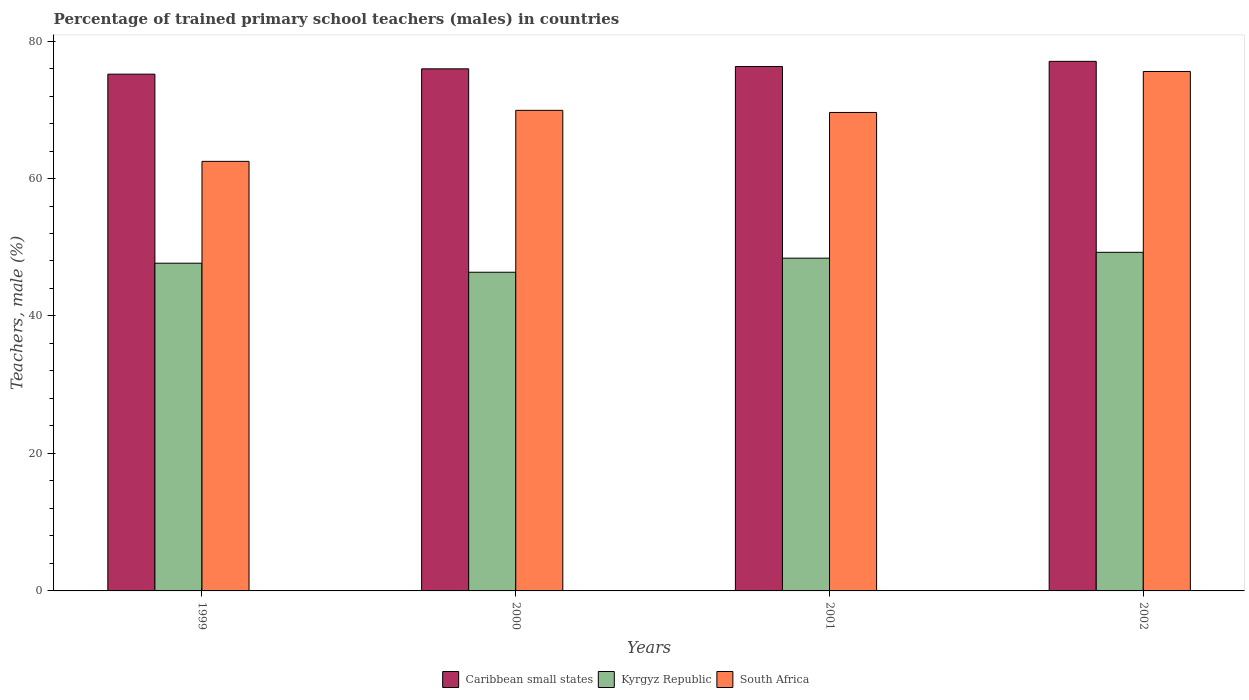How many different coloured bars are there?
Your answer should be very brief. 3. How many groups of bars are there?
Your answer should be compact. 4. Are the number of bars per tick equal to the number of legend labels?
Make the answer very short. Yes. Are the number of bars on each tick of the X-axis equal?
Your response must be concise. Yes. How many bars are there on the 4th tick from the right?
Offer a terse response. 3. What is the label of the 2nd group of bars from the left?
Your answer should be compact. 2000. In how many cases, is the number of bars for a given year not equal to the number of legend labels?
Provide a short and direct response. 0. What is the percentage of trained primary school teachers (males) in Kyrgyz Republic in 2001?
Keep it short and to the point. 48.41. Across all years, what is the maximum percentage of trained primary school teachers (males) in Caribbean small states?
Give a very brief answer. 77.04. Across all years, what is the minimum percentage of trained primary school teachers (males) in South Africa?
Offer a terse response. 62.49. What is the total percentage of trained primary school teachers (males) in Caribbean small states in the graph?
Provide a succinct answer. 304.48. What is the difference between the percentage of trained primary school teachers (males) in South Africa in 2001 and that in 2002?
Provide a succinct answer. -5.96. What is the difference between the percentage of trained primary school teachers (males) in South Africa in 2000 and the percentage of trained primary school teachers (males) in Caribbean small states in 2002?
Your answer should be very brief. -7.13. What is the average percentage of trained primary school teachers (males) in Kyrgyz Republic per year?
Your answer should be very brief. 47.93. In the year 1999, what is the difference between the percentage of trained primary school teachers (males) in Kyrgyz Republic and percentage of trained primary school teachers (males) in Caribbean small states?
Your answer should be compact. -27.5. In how many years, is the percentage of trained primary school teachers (males) in South Africa greater than 40 %?
Keep it short and to the point. 4. What is the ratio of the percentage of trained primary school teachers (males) in South Africa in 2001 to that in 2002?
Your answer should be very brief. 0.92. Is the difference between the percentage of trained primary school teachers (males) in Kyrgyz Republic in 1999 and 2001 greater than the difference between the percentage of trained primary school teachers (males) in Caribbean small states in 1999 and 2001?
Offer a terse response. Yes. What is the difference between the highest and the second highest percentage of trained primary school teachers (males) in South Africa?
Provide a short and direct response. 5.65. What is the difference between the highest and the lowest percentage of trained primary school teachers (males) in South Africa?
Provide a short and direct response. 13.08. In how many years, is the percentage of trained primary school teachers (males) in Kyrgyz Republic greater than the average percentage of trained primary school teachers (males) in Kyrgyz Republic taken over all years?
Give a very brief answer. 2. Is the sum of the percentage of trained primary school teachers (males) in Caribbean small states in 1999 and 2001 greater than the maximum percentage of trained primary school teachers (males) in Kyrgyz Republic across all years?
Offer a terse response. Yes. What does the 2nd bar from the left in 2002 represents?
Offer a very short reply. Kyrgyz Republic. What does the 1st bar from the right in 2001 represents?
Your response must be concise. South Africa. Is it the case that in every year, the sum of the percentage of trained primary school teachers (males) in Kyrgyz Republic and percentage of trained primary school teachers (males) in South Africa is greater than the percentage of trained primary school teachers (males) in Caribbean small states?
Ensure brevity in your answer.  Yes. What is the difference between two consecutive major ticks on the Y-axis?
Ensure brevity in your answer.  20. Does the graph contain any zero values?
Offer a very short reply. No. How many legend labels are there?
Give a very brief answer. 3. What is the title of the graph?
Your response must be concise. Percentage of trained primary school teachers (males) in countries. Does "Slovak Republic" appear as one of the legend labels in the graph?
Give a very brief answer. No. What is the label or title of the Y-axis?
Your answer should be compact. Teachers, male (%). What is the Teachers, male (%) of Caribbean small states in 1999?
Ensure brevity in your answer.  75.18. What is the Teachers, male (%) in Kyrgyz Republic in 1999?
Your answer should be very brief. 47.68. What is the Teachers, male (%) of South Africa in 1999?
Keep it short and to the point. 62.49. What is the Teachers, male (%) in Caribbean small states in 2000?
Your response must be concise. 75.96. What is the Teachers, male (%) of Kyrgyz Republic in 2000?
Provide a short and direct response. 46.36. What is the Teachers, male (%) of South Africa in 2000?
Your answer should be compact. 69.92. What is the Teachers, male (%) in Caribbean small states in 2001?
Your response must be concise. 76.3. What is the Teachers, male (%) in Kyrgyz Republic in 2001?
Provide a succinct answer. 48.41. What is the Teachers, male (%) in South Africa in 2001?
Keep it short and to the point. 69.61. What is the Teachers, male (%) of Caribbean small states in 2002?
Ensure brevity in your answer.  77.04. What is the Teachers, male (%) in Kyrgyz Republic in 2002?
Ensure brevity in your answer.  49.26. What is the Teachers, male (%) in South Africa in 2002?
Make the answer very short. 75.57. Across all years, what is the maximum Teachers, male (%) in Caribbean small states?
Make the answer very short. 77.04. Across all years, what is the maximum Teachers, male (%) of Kyrgyz Republic?
Your answer should be compact. 49.26. Across all years, what is the maximum Teachers, male (%) in South Africa?
Make the answer very short. 75.57. Across all years, what is the minimum Teachers, male (%) of Caribbean small states?
Your answer should be compact. 75.18. Across all years, what is the minimum Teachers, male (%) in Kyrgyz Republic?
Make the answer very short. 46.36. Across all years, what is the minimum Teachers, male (%) of South Africa?
Give a very brief answer. 62.49. What is the total Teachers, male (%) of Caribbean small states in the graph?
Offer a terse response. 304.48. What is the total Teachers, male (%) of Kyrgyz Republic in the graph?
Your answer should be very brief. 191.71. What is the total Teachers, male (%) in South Africa in the graph?
Give a very brief answer. 277.59. What is the difference between the Teachers, male (%) of Caribbean small states in 1999 and that in 2000?
Make the answer very short. -0.77. What is the difference between the Teachers, male (%) in Kyrgyz Republic in 1999 and that in 2000?
Make the answer very short. 1.32. What is the difference between the Teachers, male (%) of South Africa in 1999 and that in 2000?
Provide a succinct answer. -7.42. What is the difference between the Teachers, male (%) in Caribbean small states in 1999 and that in 2001?
Provide a succinct answer. -1.12. What is the difference between the Teachers, male (%) in Kyrgyz Republic in 1999 and that in 2001?
Provide a short and direct response. -0.73. What is the difference between the Teachers, male (%) of South Africa in 1999 and that in 2001?
Your response must be concise. -7.12. What is the difference between the Teachers, male (%) in Caribbean small states in 1999 and that in 2002?
Provide a succinct answer. -1.86. What is the difference between the Teachers, male (%) of Kyrgyz Republic in 1999 and that in 2002?
Make the answer very short. -1.58. What is the difference between the Teachers, male (%) of South Africa in 1999 and that in 2002?
Offer a terse response. -13.08. What is the difference between the Teachers, male (%) in Caribbean small states in 2000 and that in 2001?
Ensure brevity in your answer.  -0.34. What is the difference between the Teachers, male (%) in Kyrgyz Republic in 2000 and that in 2001?
Provide a succinct answer. -2.05. What is the difference between the Teachers, male (%) in South Africa in 2000 and that in 2001?
Offer a terse response. 0.31. What is the difference between the Teachers, male (%) in Caribbean small states in 2000 and that in 2002?
Offer a terse response. -1.09. What is the difference between the Teachers, male (%) of Kyrgyz Republic in 2000 and that in 2002?
Provide a succinct answer. -2.9. What is the difference between the Teachers, male (%) in South Africa in 2000 and that in 2002?
Provide a short and direct response. -5.65. What is the difference between the Teachers, male (%) in Caribbean small states in 2001 and that in 2002?
Give a very brief answer. -0.75. What is the difference between the Teachers, male (%) of Kyrgyz Republic in 2001 and that in 2002?
Provide a succinct answer. -0.85. What is the difference between the Teachers, male (%) of South Africa in 2001 and that in 2002?
Offer a terse response. -5.96. What is the difference between the Teachers, male (%) in Caribbean small states in 1999 and the Teachers, male (%) in Kyrgyz Republic in 2000?
Offer a terse response. 28.82. What is the difference between the Teachers, male (%) in Caribbean small states in 1999 and the Teachers, male (%) in South Africa in 2000?
Provide a succinct answer. 5.26. What is the difference between the Teachers, male (%) in Kyrgyz Republic in 1999 and the Teachers, male (%) in South Africa in 2000?
Provide a succinct answer. -22.24. What is the difference between the Teachers, male (%) of Caribbean small states in 1999 and the Teachers, male (%) of Kyrgyz Republic in 2001?
Offer a terse response. 26.77. What is the difference between the Teachers, male (%) in Caribbean small states in 1999 and the Teachers, male (%) in South Africa in 2001?
Offer a terse response. 5.57. What is the difference between the Teachers, male (%) of Kyrgyz Republic in 1999 and the Teachers, male (%) of South Africa in 2001?
Your response must be concise. -21.93. What is the difference between the Teachers, male (%) in Caribbean small states in 1999 and the Teachers, male (%) in Kyrgyz Republic in 2002?
Your answer should be very brief. 25.92. What is the difference between the Teachers, male (%) in Caribbean small states in 1999 and the Teachers, male (%) in South Africa in 2002?
Give a very brief answer. -0.39. What is the difference between the Teachers, male (%) of Kyrgyz Republic in 1999 and the Teachers, male (%) of South Africa in 2002?
Your answer should be compact. -27.89. What is the difference between the Teachers, male (%) in Caribbean small states in 2000 and the Teachers, male (%) in Kyrgyz Republic in 2001?
Your response must be concise. 27.55. What is the difference between the Teachers, male (%) of Caribbean small states in 2000 and the Teachers, male (%) of South Africa in 2001?
Give a very brief answer. 6.35. What is the difference between the Teachers, male (%) of Kyrgyz Republic in 2000 and the Teachers, male (%) of South Africa in 2001?
Keep it short and to the point. -23.25. What is the difference between the Teachers, male (%) in Caribbean small states in 2000 and the Teachers, male (%) in Kyrgyz Republic in 2002?
Provide a succinct answer. 26.69. What is the difference between the Teachers, male (%) of Caribbean small states in 2000 and the Teachers, male (%) of South Africa in 2002?
Make the answer very short. 0.38. What is the difference between the Teachers, male (%) of Kyrgyz Republic in 2000 and the Teachers, male (%) of South Africa in 2002?
Give a very brief answer. -29.21. What is the difference between the Teachers, male (%) in Caribbean small states in 2001 and the Teachers, male (%) in Kyrgyz Republic in 2002?
Your response must be concise. 27.04. What is the difference between the Teachers, male (%) of Caribbean small states in 2001 and the Teachers, male (%) of South Africa in 2002?
Your response must be concise. 0.73. What is the difference between the Teachers, male (%) in Kyrgyz Republic in 2001 and the Teachers, male (%) in South Africa in 2002?
Give a very brief answer. -27.16. What is the average Teachers, male (%) in Caribbean small states per year?
Provide a succinct answer. 76.12. What is the average Teachers, male (%) of Kyrgyz Republic per year?
Offer a terse response. 47.93. What is the average Teachers, male (%) of South Africa per year?
Ensure brevity in your answer.  69.4. In the year 1999, what is the difference between the Teachers, male (%) of Caribbean small states and Teachers, male (%) of Kyrgyz Republic?
Your response must be concise. 27.5. In the year 1999, what is the difference between the Teachers, male (%) in Caribbean small states and Teachers, male (%) in South Africa?
Your answer should be compact. 12.69. In the year 1999, what is the difference between the Teachers, male (%) in Kyrgyz Republic and Teachers, male (%) in South Africa?
Your answer should be very brief. -14.82. In the year 2000, what is the difference between the Teachers, male (%) in Caribbean small states and Teachers, male (%) in Kyrgyz Republic?
Make the answer very short. 29.59. In the year 2000, what is the difference between the Teachers, male (%) of Caribbean small states and Teachers, male (%) of South Africa?
Your answer should be very brief. 6.04. In the year 2000, what is the difference between the Teachers, male (%) in Kyrgyz Republic and Teachers, male (%) in South Africa?
Your answer should be very brief. -23.56. In the year 2001, what is the difference between the Teachers, male (%) of Caribbean small states and Teachers, male (%) of Kyrgyz Republic?
Make the answer very short. 27.89. In the year 2001, what is the difference between the Teachers, male (%) of Caribbean small states and Teachers, male (%) of South Africa?
Ensure brevity in your answer.  6.69. In the year 2001, what is the difference between the Teachers, male (%) in Kyrgyz Republic and Teachers, male (%) in South Africa?
Make the answer very short. -21.2. In the year 2002, what is the difference between the Teachers, male (%) in Caribbean small states and Teachers, male (%) in Kyrgyz Republic?
Offer a very short reply. 27.78. In the year 2002, what is the difference between the Teachers, male (%) of Caribbean small states and Teachers, male (%) of South Africa?
Offer a very short reply. 1.47. In the year 2002, what is the difference between the Teachers, male (%) of Kyrgyz Republic and Teachers, male (%) of South Africa?
Your response must be concise. -26.31. What is the ratio of the Teachers, male (%) in Caribbean small states in 1999 to that in 2000?
Ensure brevity in your answer.  0.99. What is the ratio of the Teachers, male (%) in Kyrgyz Republic in 1999 to that in 2000?
Keep it short and to the point. 1.03. What is the ratio of the Teachers, male (%) in South Africa in 1999 to that in 2000?
Give a very brief answer. 0.89. What is the ratio of the Teachers, male (%) of Caribbean small states in 1999 to that in 2001?
Ensure brevity in your answer.  0.99. What is the ratio of the Teachers, male (%) of Kyrgyz Republic in 1999 to that in 2001?
Make the answer very short. 0.98. What is the ratio of the Teachers, male (%) in South Africa in 1999 to that in 2001?
Give a very brief answer. 0.9. What is the ratio of the Teachers, male (%) in Caribbean small states in 1999 to that in 2002?
Provide a short and direct response. 0.98. What is the ratio of the Teachers, male (%) in Kyrgyz Republic in 1999 to that in 2002?
Ensure brevity in your answer.  0.97. What is the ratio of the Teachers, male (%) of South Africa in 1999 to that in 2002?
Give a very brief answer. 0.83. What is the ratio of the Teachers, male (%) of Caribbean small states in 2000 to that in 2001?
Offer a terse response. 1. What is the ratio of the Teachers, male (%) of Kyrgyz Republic in 2000 to that in 2001?
Make the answer very short. 0.96. What is the ratio of the Teachers, male (%) of Caribbean small states in 2000 to that in 2002?
Offer a terse response. 0.99. What is the ratio of the Teachers, male (%) of South Africa in 2000 to that in 2002?
Provide a short and direct response. 0.93. What is the ratio of the Teachers, male (%) of Caribbean small states in 2001 to that in 2002?
Give a very brief answer. 0.99. What is the ratio of the Teachers, male (%) of Kyrgyz Republic in 2001 to that in 2002?
Keep it short and to the point. 0.98. What is the ratio of the Teachers, male (%) of South Africa in 2001 to that in 2002?
Ensure brevity in your answer.  0.92. What is the difference between the highest and the second highest Teachers, male (%) in Caribbean small states?
Provide a succinct answer. 0.75. What is the difference between the highest and the second highest Teachers, male (%) in Kyrgyz Republic?
Offer a very short reply. 0.85. What is the difference between the highest and the second highest Teachers, male (%) in South Africa?
Your answer should be very brief. 5.65. What is the difference between the highest and the lowest Teachers, male (%) of Caribbean small states?
Offer a very short reply. 1.86. What is the difference between the highest and the lowest Teachers, male (%) of Kyrgyz Republic?
Provide a succinct answer. 2.9. What is the difference between the highest and the lowest Teachers, male (%) of South Africa?
Keep it short and to the point. 13.08. 